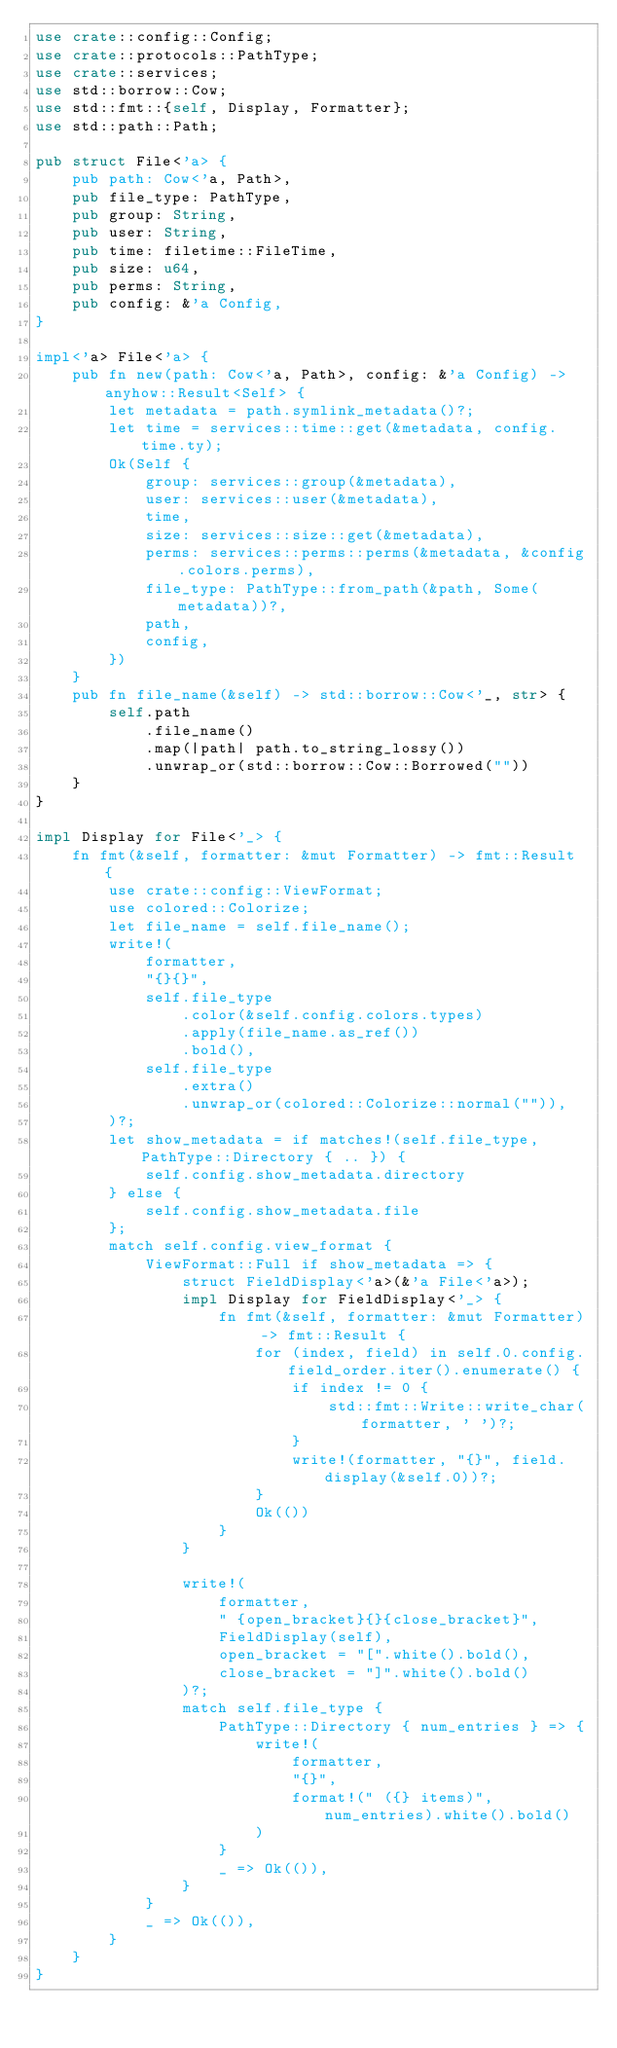Convert code to text. <code><loc_0><loc_0><loc_500><loc_500><_Rust_>use crate::config::Config;
use crate::protocols::PathType;
use crate::services;
use std::borrow::Cow;
use std::fmt::{self, Display, Formatter};
use std::path::Path;

pub struct File<'a> {
    pub path: Cow<'a, Path>,
    pub file_type: PathType,
    pub group: String,
    pub user: String,
    pub time: filetime::FileTime,
    pub size: u64,
    pub perms: String,
    pub config: &'a Config,
}

impl<'a> File<'a> {
    pub fn new(path: Cow<'a, Path>, config: &'a Config) -> anyhow::Result<Self> {
        let metadata = path.symlink_metadata()?;
        let time = services::time::get(&metadata, config.time.ty);
        Ok(Self {
            group: services::group(&metadata),
            user: services::user(&metadata),
            time,
            size: services::size::get(&metadata),
            perms: services::perms::perms(&metadata, &config.colors.perms),
            file_type: PathType::from_path(&path, Some(metadata))?,
            path,
            config,
        })
    }
    pub fn file_name(&self) -> std::borrow::Cow<'_, str> {
        self.path
            .file_name()
            .map(|path| path.to_string_lossy())
            .unwrap_or(std::borrow::Cow::Borrowed(""))
    }
}

impl Display for File<'_> {
    fn fmt(&self, formatter: &mut Formatter) -> fmt::Result {
        use crate::config::ViewFormat;
        use colored::Colorize;
        let file_name = self.file_name();
        write!(
            formatter,
            "{}{}",
            self.file_type
                .color(&self.config.colors.types)
                .apply(file_name.as_ref())
                .bold(),
            self.file_type
                .extra()
                .unwrap_or(colored::Colorize::normal("")),
        )?;
        let show_metadata = if matches!(self.file_type, PathType::Directory { .. }) {
            self.config.show_metadata.directory
        } else {
            self.config.show_metadata.file
        };
        match self.config.view_format {
            ViewFormat::Full if show_metadata => {
                struct FieldDisplay<'a>(&'a File<'a>);
                impl Display for FieldDisplay<'_> {
                    fn fmt(&self, formatter: &mut Formatter) -> fmt::Result {
                        for (index, field) in self.0.config.field_order.iter().enumerate() {
                            if index != 0 {
                                std::fmt::Write::write_char(formatter, ' ')?;
                            }
                            write!(formatter, "{}", field.display(&self.0))?;
                        }
                        Ok(())
                    }
                }

                write!(
                    formatter,
                    " {open_bracket}{}{close_bracket}",
                    FieldDisplay(self),
                    open_bracket = "[".white().bold(),
                    close_bracket = "]".white().bold()
                )?;
                match self.file_type {
                    PathType::Directory { num_entries } => {
                        write!(
                            formatter,
                            "{}",
                            format!(" ({} items)", num_entries).white().bold()
                        )
                    }
                    _ => Ok(()),
                }
            }
            _ => Ok(()),
        }
    }
}
</code> 